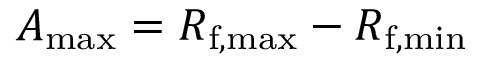Convert formula to latex. <formula><loc_0><loc_0><loc_500><loc_500>A _ { \max } = R _ { f , \max } - R _ { f , \min }</formula> 